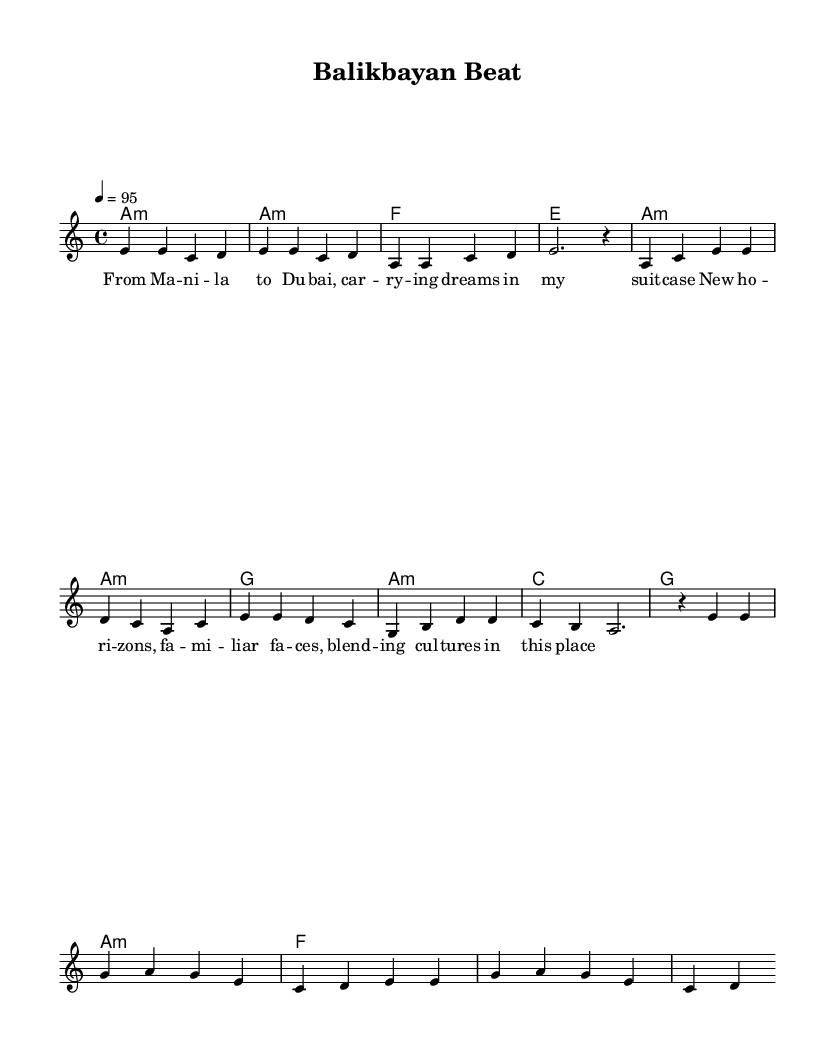What is the key signature of this music? The key signature is A minor, which contains no sharps and is identified by the absence of a sharp or flat symbol at the beginning of the staff.
Answer: A minor What is the time signature of this music? The time signature is 4/4, represented by the numbers indicating four beats per measure and the quarter note gets one beat, typically seen at the beginning of the score.
Answer: 4/4 What is the tempo marking for this piece? The tempo marking indicates a speed of 95 beats per minute, noted at the beginning of the score with "4 = 95".
Answer: 95 What chords are primarily used in the verse? The primary chords used in the verse are A minor and G, identified in the harmony section under the verse, displayed in the chord mode.
Answer: A minor, G How many measures are in the chorus section? The chorus section consists of four measures, counted from the beginning of the chorus section to the end of the last chord of the chorus.
Answer: 4 What themes are reflected in the lyrics of this piece? The lyrics reflect themes of migration and cultural identity, as indicated by the phrases about carrying dreams and blending cultures, which are clear in the text itself.
Answer: Migration, cultural identity What is the purpose of the intro section in this music? The intro section serves to establish the rhythm and mood of the piece, as indicated by the melodic and harmonic material presented before the verse starts.
Answer: Establish mood 